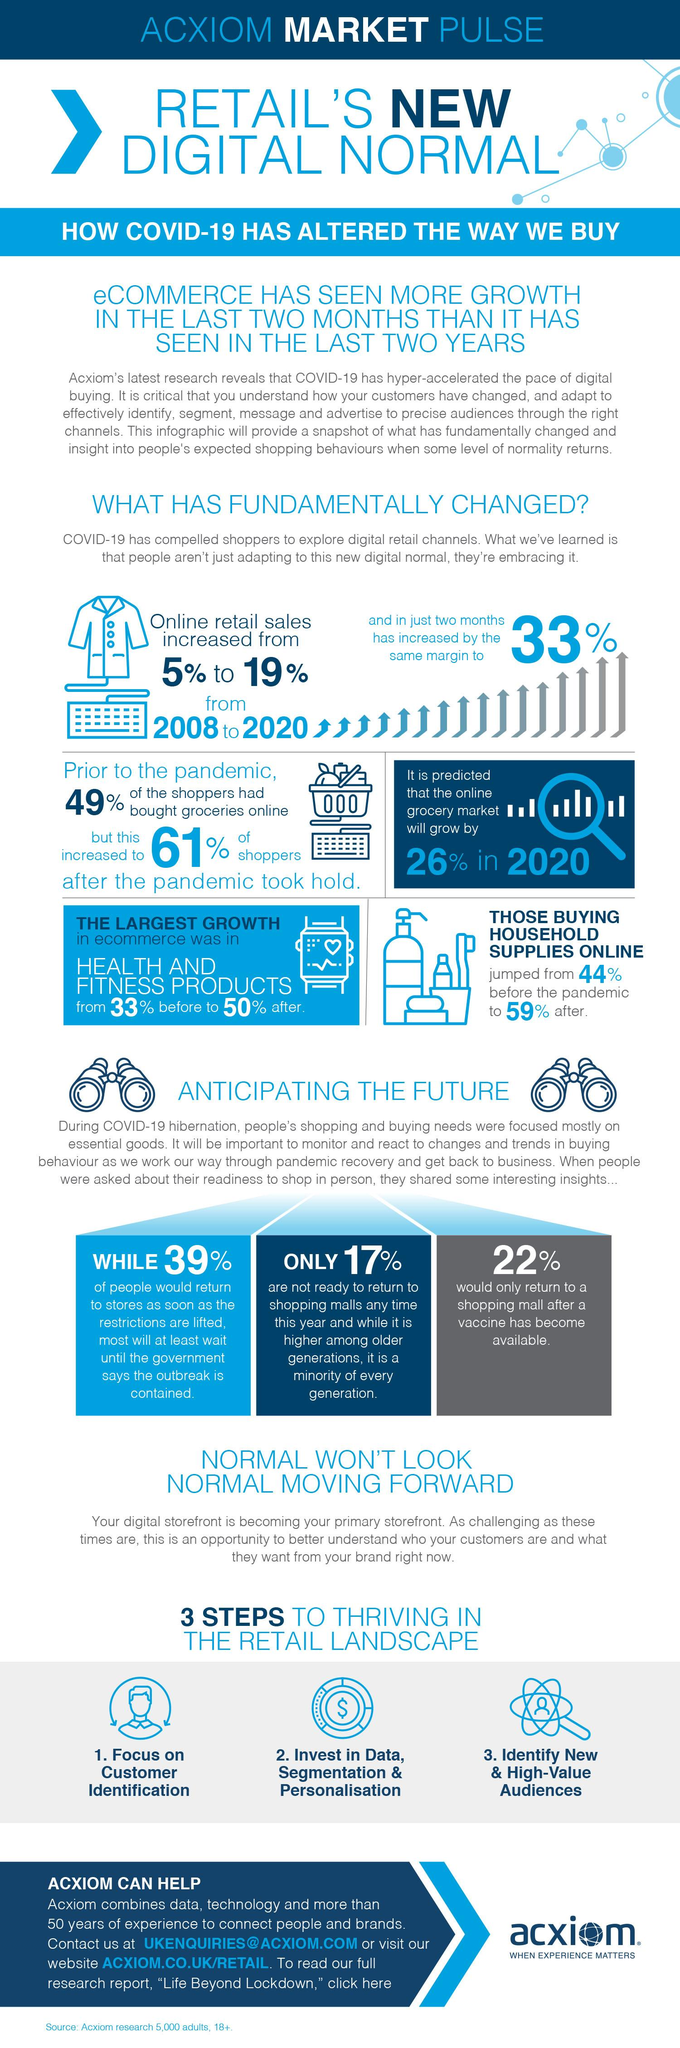Highlight a few significant elements in this photo. The online grocery market is expected to experience a predicted increase of 26% in 2020. According to a recent survey, 22% of people stated that they would only return to a shopping mall after a vaccine for Covid-19 has become available. According to the survey, 39% of people would return to stores as soon as the government restrictions are lifted. After the COVID-19 outbreak in 2020, 59% of people preferred to buy household supplies online. 